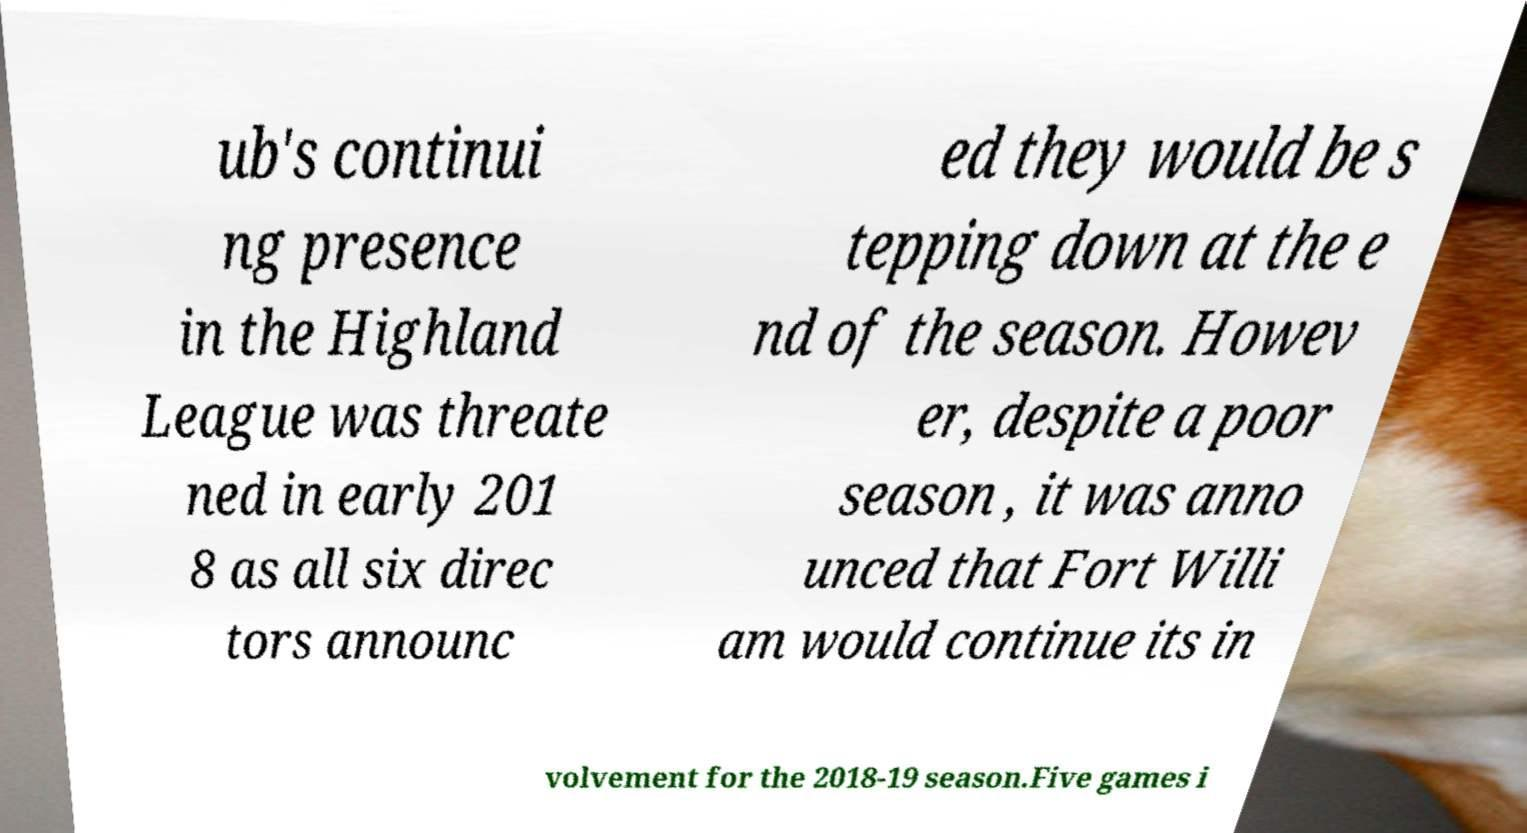Please identify and transcribe the text found in this image. ub's continui ng presence in the Highland League was threate ned in early 201 8 as all six direc tors announc ed they would be s tepping down at the e nd of the season. Howev er, despite a poor season , it was anno unced that Fort Willi am would continue its in volvement for the 2018-19 season.Five games i 